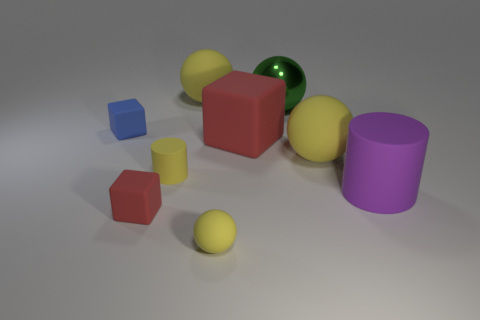There is a big thing that is the same shape as the tiny red thing; what is its color?
Ensure brevity in your answer.  Red. There is a block that is in front of the large block; what is its material?
Provide a succinct answer. Rubber. The large metallic sphere has what color?
Provide a short and direct response. Green. There is a yellow ball behind the blue rubber block; does it have the same size as the big purple object?
Make the answer very short. Yes. What is the material of the block to the right of the tiny yellow matte cylinder behind the small red object that is to the left of the small sphere?
Offer a very short reply. Rubber. Does the small matte cube that is in front of the yellow cylinder have the same color as the tiny cube behind the small red matte object?
Provide a short and direct response. No. What is the material of the cube that is right of the small yellow object in front of the purple thing?
Keep it short and to the point. Rubber. The block that is the same size as the blue rubber object is what color?
Offer a very short reply. Red. There is a tiny red rubber object; is its shape the same as the big yellow thing that is to the right of the green ball?
Your answer should be compact. No. What shape is the small matte thing that is the same color as the small cylinder?
Ensure brevity in your answer.  Sphere. 